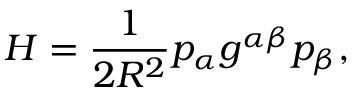<formula> <loc_0><loc_0><loc_500><loc_500>H = \frac { 1 } { 2 R ^ { 2 } } p _ { \alpha } g ^ { \alpha \beta } p _ { \beta } ,</formula> 